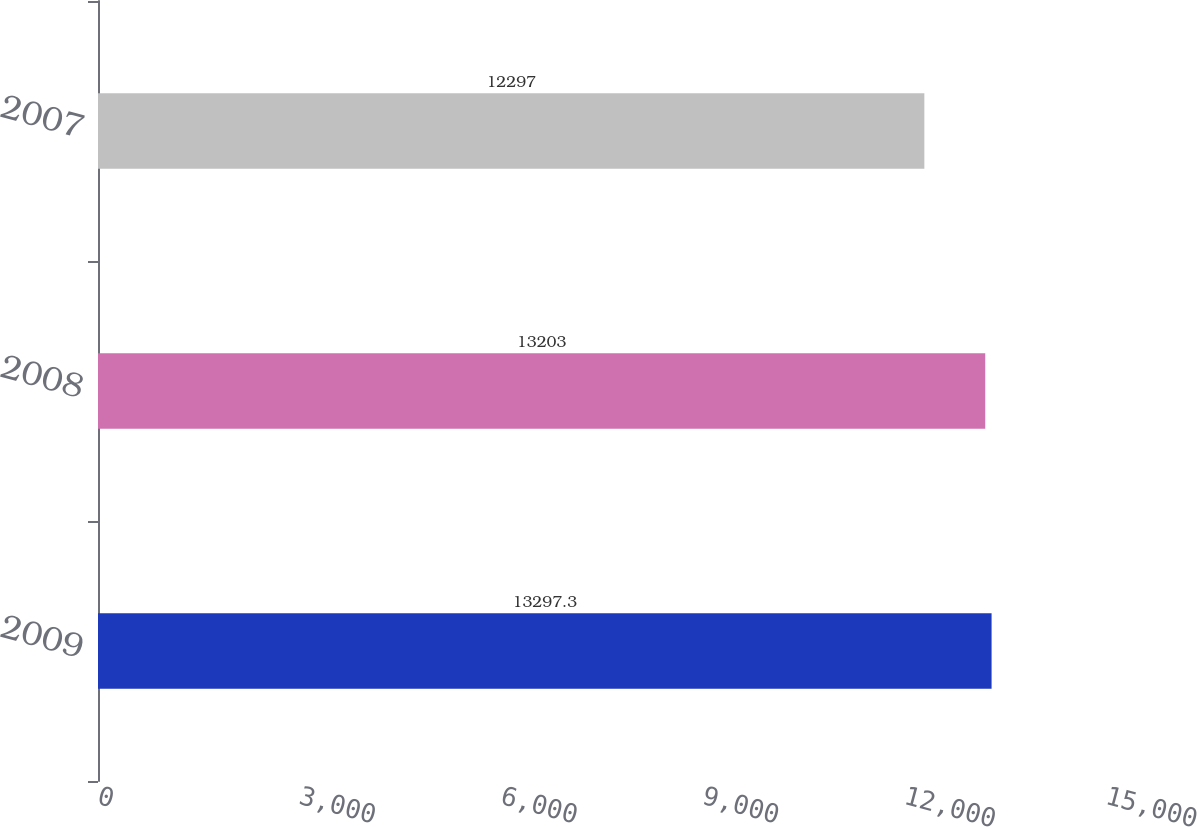<chart> <loc_0><loc_0><loc_500><loc_500><bar_chart><fcel>2009<fcel>2008<fcel>2007<nl><fcel>13297.3<fcel>13203<fcel>12297<nl></chart> 